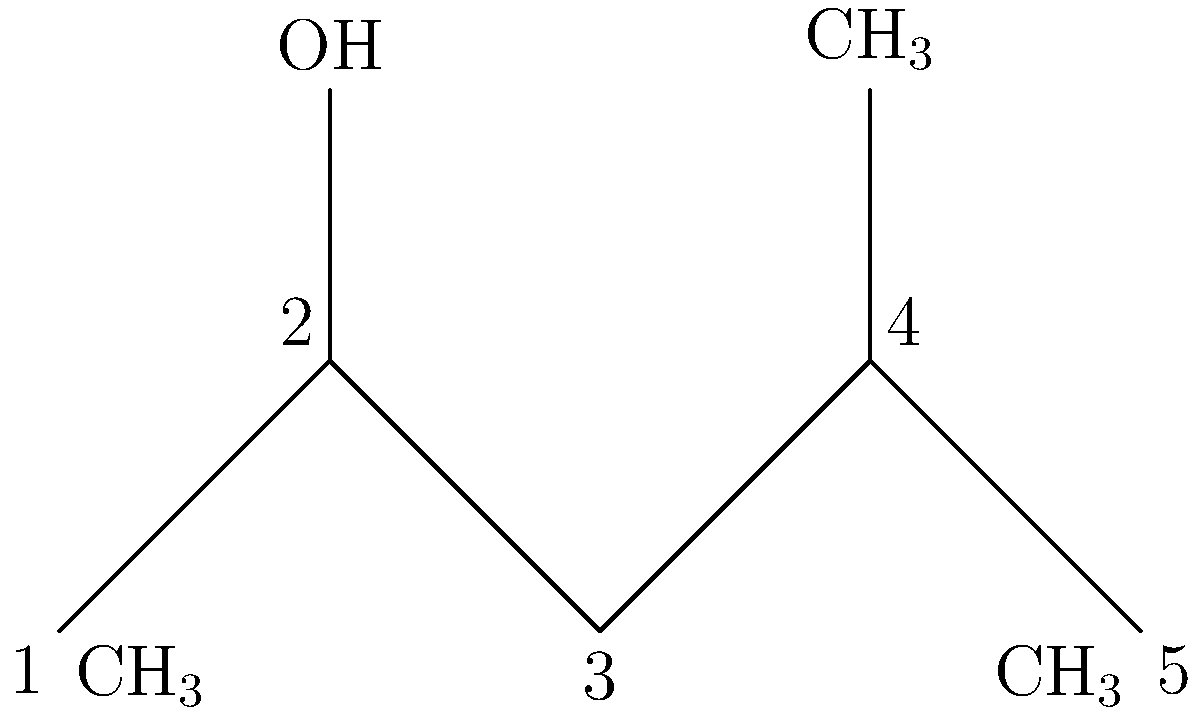As a petrochemical engineer, analyze the skeletal formula diagram of this hydrocarbon compound. What is the molecular formula of this compound, and what class of organic compounds does it belong to? Let's analyze this skeletal formula step-by-step:

1. Count the carbon atoms:
   - There are 5 vertices in the skeletal structure, each representing a carbon atom.

2. Identify the functional groups:
   - There is an OH group attached to the second carbon.
   - There are three CH$_3$ (methyl) groups: one at the first carbon, one at the fourth carbon, and one at the fifth carbon.

3. Count the hydrogen atoms:
   - The OH group contributes 1 H
   - The three CH$_3$ groups contribute 3 × 3 = 9 H
   - The remaining two carbons (3rd and 4th) each have 1 H
   - Total H count: 1 + 9 + 2 = 12 H

4. Formulate the molecular formula:
   - 5 carbon atoms and 12 hydrogen atoms, plus 1 oxygen atom from the OH group
   - Therefore, the molecular formula is C$_5$H$_{12}$O

5. Identify the class of organic compounds:
   - The presence of an OH group attached to a saturated carbon chain classifies this compound as an alcohol.
   - Specifically, it's a secondary alcohol because the OH group is attached to a carbon that is bonded to two other carbon atoms.
Answer: C$_5$H$_{12}$O; Secondary alcohol 